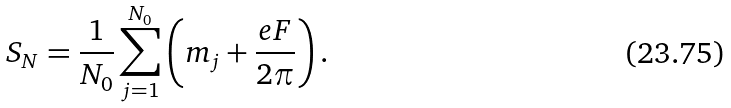<formula> <loc_0><loc_0><loc_500><loc_500>S _ { N } = \frac { 1 } { N _ { 0 } } \sum _ { j = 1 } ^ { N _ { 0 } } \left ( m _ { j } + \frac { e F } { 2 \pi } \right ) .</formula> 